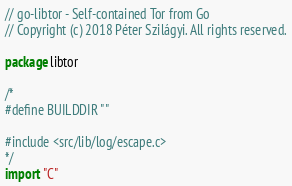<code> <loc_0><loc_0><loc_500><loc_500><_Go_>// go-libtor - Self-contained Tor from Go
// Copyright (c) 2018 Péter Szilágyi. All rights reserved.

package libtor

/*
#define BUILDDIR ""

#include <src/lib/log/escape.c>
*/
import "C"
</code> 